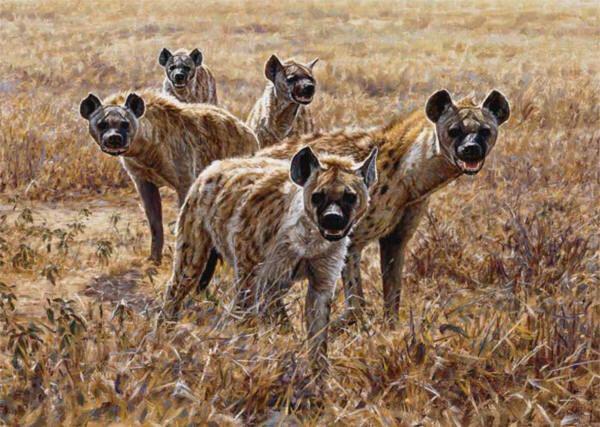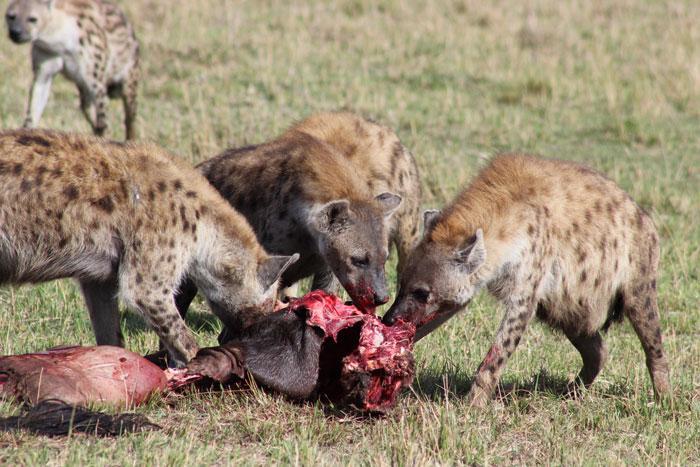The first image is the image on the left, the second image is the image on the right. Given the left and right images, does the statement "An open-mouthed lion is near a hyena in one image." hold true? Answer yes or no. No. 